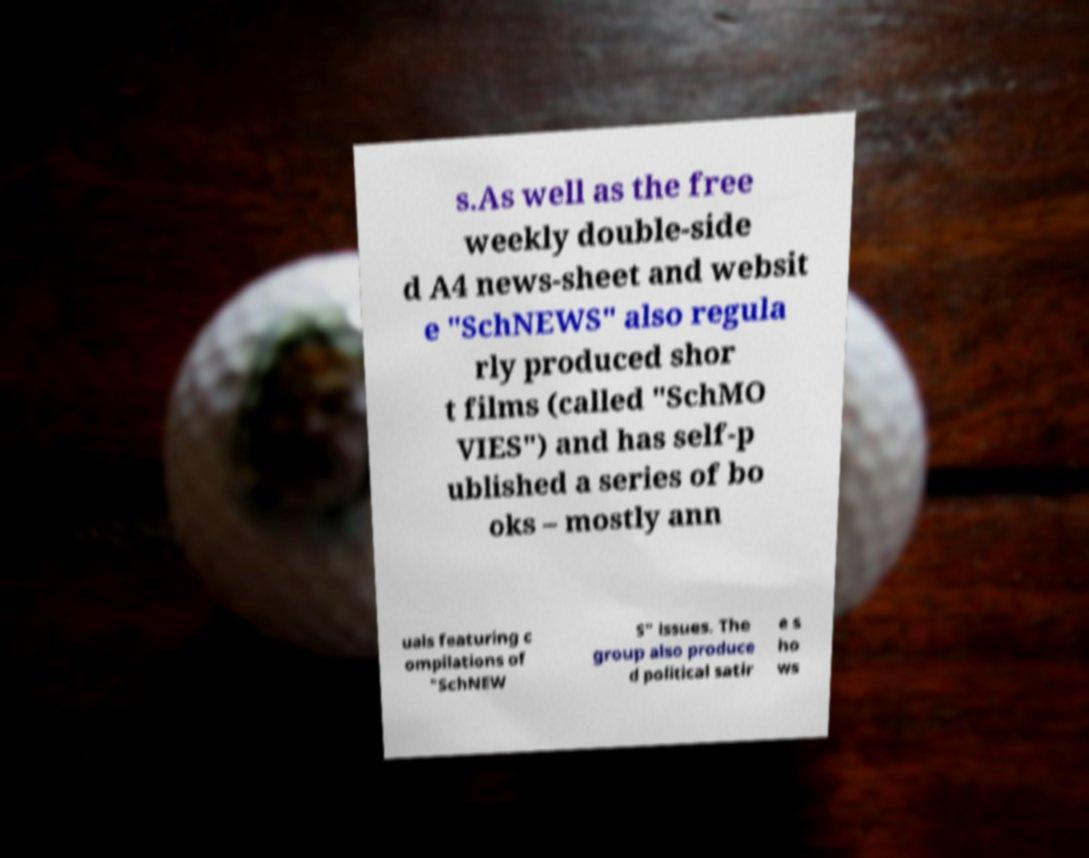I need the written content from this picture converted into text. Can you do that? s.As well as the free weekly double-side d A4 news-sheet and websit e "SchNEWS" also regula rly produced shor t films (called "SchMO VIES") and has self-p ublished a series of bo oks – mostly ann uals featuring c ompilations of "SchNEW S" issues. The group also produce d political satir e s ho ws 